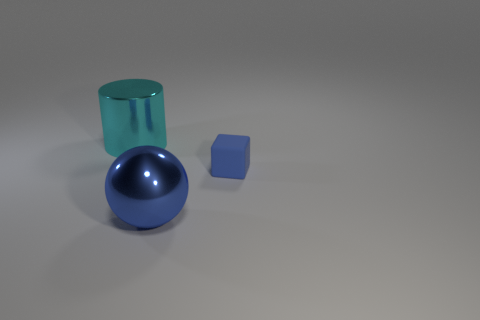Add 1 blue shiny balls. How many objects exist? 4 Subtract 1 cubes. How many cubes are left? 0 Subtract all tiny blue objects. Subtract all cylinders. How many objects are left? 1 Add 3 cyan metal things. How many cyan metal things are left? 4 Add 3 large cyan cylinders. How many large cyan cylinders exist? 4 Subtract 0 purple cylinders. How many objects are left? 3 Subtract all balls. How many objects are left? 2 